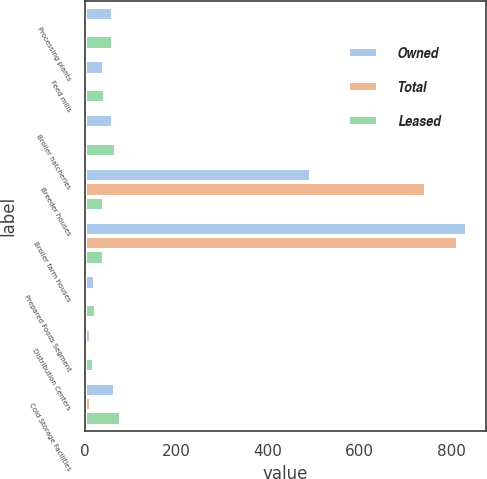Convert chart. <chart><loc_0><loc_0><loc_500><loc_500><stacked_bar_chart><ecel><fcel>Processing plants<fcel>Feed mills<fcel>Broiler hatcheries<fcel>Breeder houses<fcel>Broiler farm houses<fcel>Prepared Foods Segment<fcel>Distribution Centers<fcel>Cold Storage Facilities<nl><fcel>Owned<fcel>61<fcel>42<fcel>62<fcel>493<fcel>834<fcel>22<fcel>14<fcel>65<nl><fcel>Total<fcel>1<fcel>1<fcel>5<fcel>744<fcel>816<fcel>1<fcel>5<fcel>13<nl><fcel>Leased<fcel>62<fcel>43<fcel>67<fcel>42.5<fcel>42.5<fcel>23<fcel>19<fcel>78<nl></chart> 